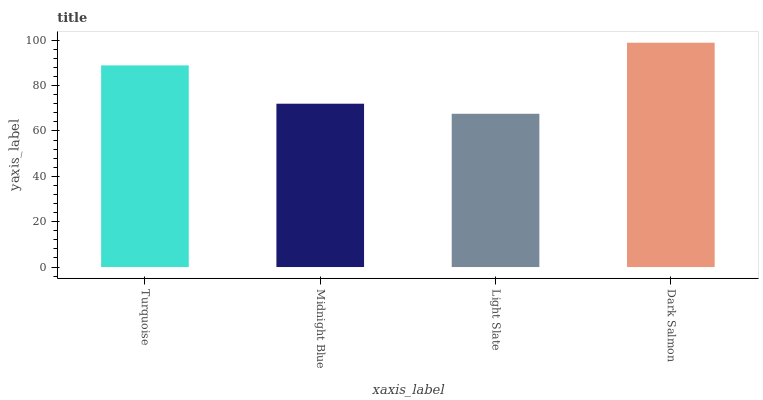Is Midnight Blue the minimum?
Answer yes or no. No. Is Midnight Blue the maximum?
Answer yes or no. No. Is Turquoise greater than Midnight Blue?
Answer yes or no. Yes. Is Midnight Blue less than Turquoise?
Answer yes or no. Yes. Is Midnight Blue greater than Turquoise?
Answer yes or no. No. Is Turquoise less than Midnight Blue?
Answer yes or no. No. Is Turquoise the high median?
Answer yes or no. Yes. Is Midnight Blue the low median?
Answer yes or no. Yes. Is Light Slate the high median?
Answer yes or no. No. Is Dark Salmon the low median?
Answer yes or no. No. 